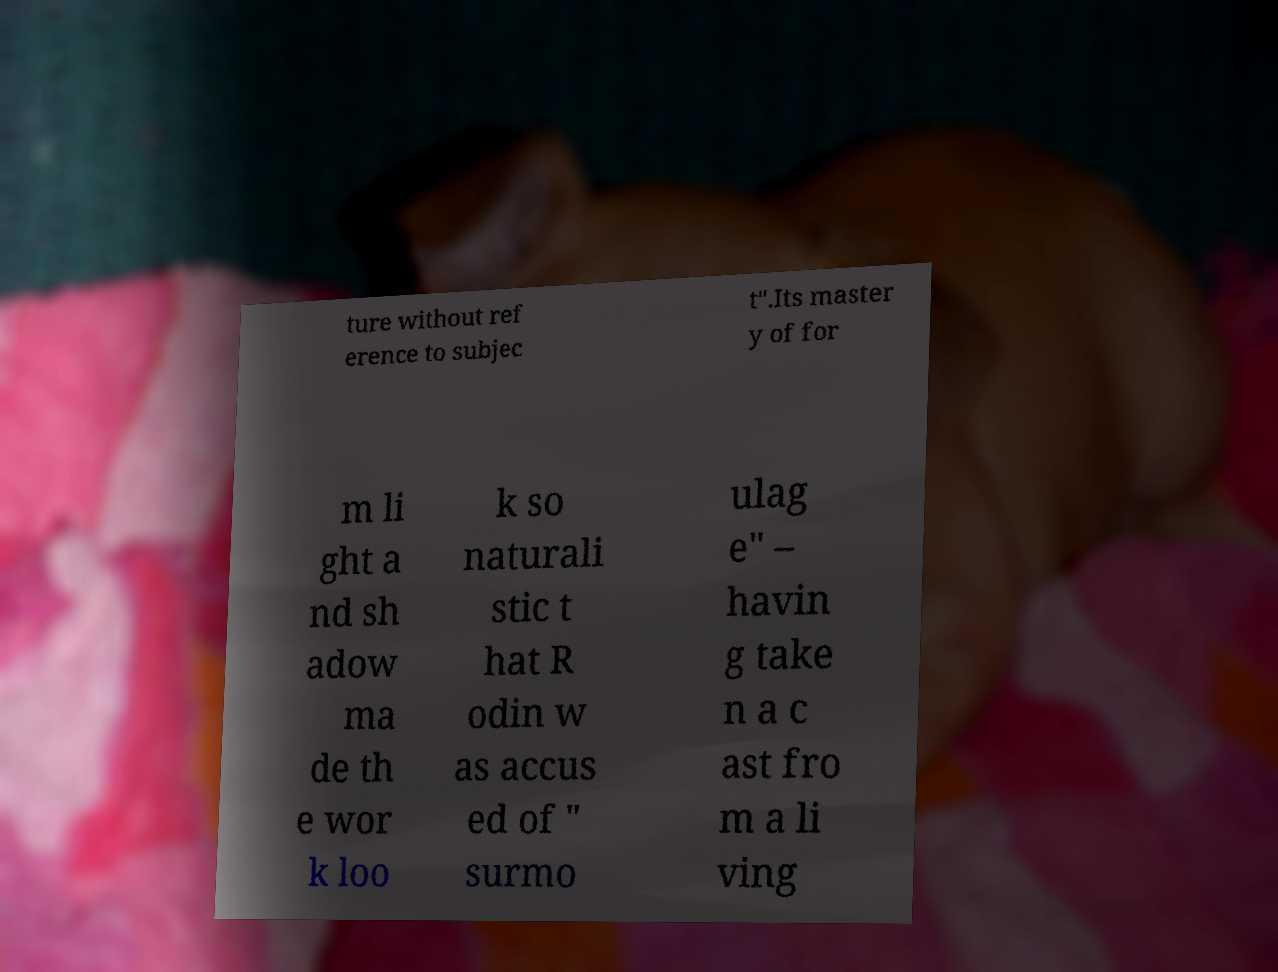Please read and relay the text visible in this image. What does it say? ture without ref erence to subjec t".Its master y of for m li ght a nd sh adow ma de th e wor k loo k so naturali stic t hat R odin w as accus ed of " surmo ulag e" – havin g take n a c ast fro m a li ving 